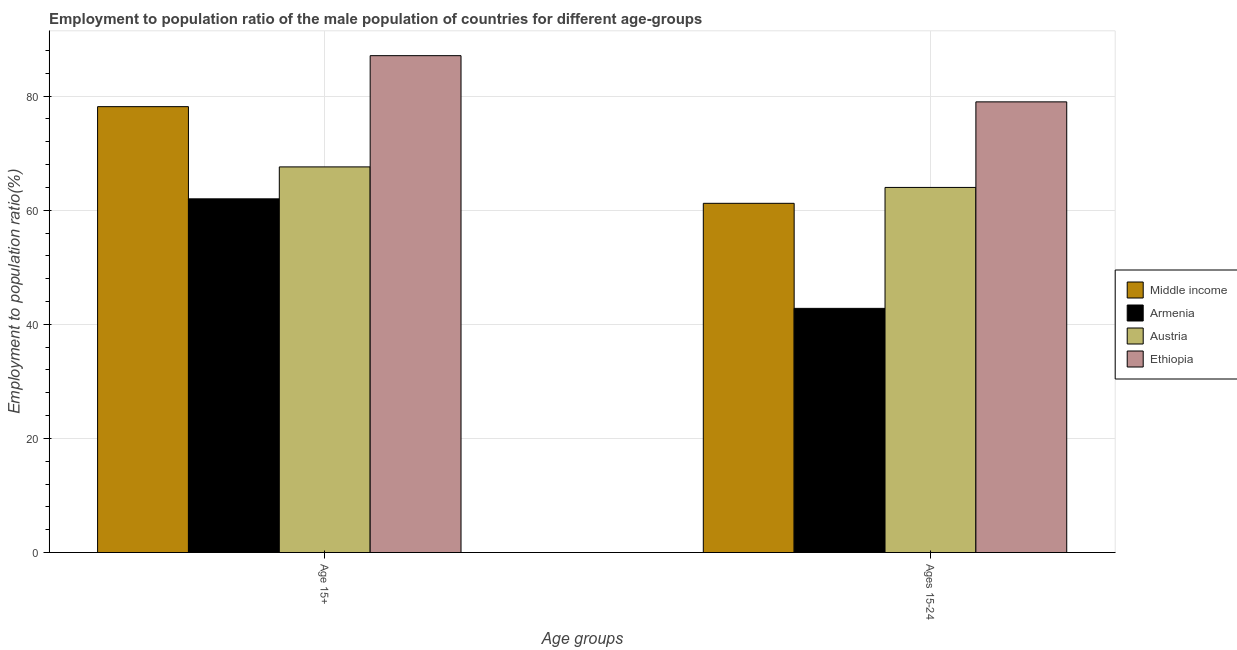How many different coloured bars are there?
Provide a succinct answer. 4. How many groups of bars are there?
Make the answer very short. 2. What is the label of the 2nd group of bars from the left?
Your answer should be very brief. Ages 15-24. What is the employment to population ratio(age 15+) in Armenia?
Offer a very short reply. 62. Across all countries, what is the maximum employment to population ratio(age 15-24)?
Keep it short and to the point. 79. Across all countries, what is the minimum employment to population ratio(age 15-24)?
Offer a terse response. 42.8. In which country was the employment to population ratio(age 15-24) maximum?
Provide a succinct answer. Ethiopia. In which country was the employment to population ratio(age 15-24) minimum?
Provide a short and direct response. Armenia. What is the total employment to population ratio(age 15-24) in the graph?
Keep it short and to the point. 247.01. What is the difference between the employment to population ratio(age 15+) in Armenia and that in Middle income?
Make the answer very short. -16.16. What is the difference between the employment to population ratio(age 15+) in Ethiopia and the employment to population ratio(age 15-24) in Middle income?
Offer a very short reply. 25.89. What is the average employment to population ratio(age 15-24) per country?
Provide a succinct answer. 61.75. What is the difference between the employment to population ratio(age 15+) and employment to population ratio(age 15-24) in Ethiopia?
Your answer should be very brief. 8.1. What is the ratio of the employment to population ratio(age 15+) in Armenia to that in Austria?
Your response must be concise. 0.92. What does the 1st bar from the left in Ages 15-24 represents?
Your response must be concise. Middle income. What does the 3rd bar from the right in Age 15+ represents?
Make the answer very short. Armenia. How many bars are there?
Your answer should be compact. 8. How many countries are there in the graph?
Your response must be concise. 4. What is the difference between two consecutive major ticks on the Y-axis?
Make the answer very short. 20. Are the values on the major ticks of Y-axis written in scientific E-notation?
Provide a short and direct response. No. Does the graph contain any zero values?
Your answer should be compact. No. How are the legend labels stacked?
Your answer should be compact. Vertical. What is the title of the graph?
Your response must be concise. Employment to population ratio of the male population of countries for different age-groups. What is the label or title of the X-axis?
Provide a succinct answer. Age groups. What is the Employment to population ratio(%) in Middle income in Age 15+?
Ensure brevity in your answer.  78.16. What is the Employment to population ratio(%) in Armenia in Age 15+?
Give a very brief answer. 62. What is the Employment to population ratio(%) of Austria in Age 15+?
Your answer should be compact. 67.6. What is the Employment to population ratio(%) of Ethiopia in Age 15+?
Keep it short and to the point. 87.1. What is the Employment to population ratio(%) of Middle income in Ages 15-24?
Make the answer very short. 61.21. What is the Employment to population ratio(%) of Armenia in Ages 15-24?
Provide a short and direct response. 42.8. What is the Employment to population ratio(%) in Ethiopia in Ages 15-24?
Make the answer very short. 79. Across all Age groups, what is the maximum Employment to population ratio(%) of Middle income?
Provide a succinct answer. 78.16. Across all Age groups, what is the maximum Employment to population ratio(%) of Austria?
Keep it short and to the point. 67.6. Across all Age groups, what is the maximum Employment to population ratio(%) in Ethiopia?
Provide a succinct answer. 87.1. Across all Age groups, what is the minimum Employment to population ratio(%) in Middle income?
Offer a terse response. 61.21. Across all Age groups, what is the minimum Employment to population ratio(%) of Armenia?
Keep it short and to the point. 42.8. Across all Age groups, what is the minimum Employment to population ratio(%) in Ethiopia?
Provide a short and direct response. 79. What is the total Employment to population ratio(%) in Middle income in the graph?
Your answer should be compact. 139.38. What is the total Employment to population ratio(%) of Armenia in the graph?
Ensure brevity in your answer.  104.8. What is the total Employment to population ratio(%) of Austria in the graph?
Keep it short and to the point. 131.6. What is the total Employment to population ratio(%) in Ethiopia in the graph?
Ensure brevity in your answer.  166.1. What is the difference between the Employment to population ratio(%) in Middle income in Age 15+ and that in Ages 15-24?
Provide a short and direct response. 16.95. What is the difference between the Employment to population ratio(%) in Austria in Age 15+ and that in Ages 15-24?
Your answer should be very brief. 3.6. What is the difference between the Employment to population ratio(%) in Ethiopia in Age 15+ and that in Ages 15-24?
Your answer should be compact. 8.1. What is the difference between the Employment to population ratio(%) in Middle income in Age 15+ and the Employment to population ratio(%) in Armenia in Ages 15-24?
Give a very brief answer. 35.36. What is the difference between the Employment to population ratio(%) of Middle income in Age 15+ and the Employment to population ratio(%) of Austria in Ages 15-24?
Provide a succinct answer. 14.16. What is the difference between the Employment to population ratio(%) of Middle income in Age 15+ and the Employment to population ratio(%) of Ethiopia in Ages 15-24?
Give a very brief answer. -0.84. What is the average Employment to population ratio(%) of Middle income per Age groups?
Your response must be concise. 69.69. What is the average Employment to population ratio(%) in Armenia per Age groups?
Provide a short and direct response. 52.4. What is the average Employment to population ratio(%) of Austria per Age groups?
Your response must be concise. 65.8. What is the average Employment to population ratio(%) in Ethiopia per Age groups?
Provide a succinct answer. 83.05. What is the difference between the Employment to population ratio(%) of Middle income and Employment to population ratio(%) of Armenia in Age 15+?
Keep it short and to the point. 16.16. What is the difference between the Employment to population ratio(%) of Middle income and Employment to population ratio(%) of Austria in Age 15+?
Give a very brief answer. 10.56. What is the difference between the Employment to population ratio(%) in Middle income and Employment to population ratio(%) in Ethiopia in Age 15+?
Ensure brevity in your answer.  -8.94. What is the difference between the Employment to population ratio(%) in Armenia and Employment to population ratio(%) in Austria in Age 15+?
Ensure brevity in your answer.  -5.6. What is the difference between the Employment to population ratio(%) of Armenia and Employment to population ratio(%) of Ethiopia in Age 15+?
Ensure brevity in your answer.  -25.1. What is the difference between the Employment to population ratio(%) of Austria and Employment to population ratio(%) of Ethiopia in Age 15+?
Ensure brevity in your answer.  -19.5. What is the difference between the Employment to population ratio(%) of Middle income and Employment to population ratio(%) of Armenia in Ages 15-24?
Ensure brevity in your answer.  18.41. What is the difference between the Employment to population ratio(%) in Middle income and Employment to population ratio(%) in Austria in Ages 15-24?
Provide a succinct answer. -2.79. What is the difference between the Employment to population ratio(%) in Middle income and Employment to population ratio(%) in Ethiopia in Ages 15-24?
Ensure brevity in your answer.  -17.79. What is the difference between the Employment to population ratio(%) of Armenia and Employment to population ratio(%) of Austria in Ages 15-24?
Offer a terse response. -21.2. What is the difference between the Employment to population ratio(%) of Armenia and Employment to population ratio(%) of Ethiopia in Ages 15-24?
Your answer should be compact. -36.2. What is the difference between the Employment to population ratio(%) of Austria and Employment to population ratio(%) of Ethiopia in Ages 15-24?
Offer a terse response. -15. What is the ratio of the Employment to population ratio(%) of Middle income in Age 15+ to that in Ages 15-24?
Your response must be concise. 1.28. What is the ratio of the Employment to population ratio(%) of Armenia in Age 15+ to that in Ages 15-24?
Offer a terse response. 1.45. What is the ratio of the Employment to population ratio(%) in Austria in Age 15+ to that in Ages 15-24?
Keep it short and to the point. 1.06. What is the ratio of the Employment to population ratio(%) of Ethiopia in Age 15+ to that in Ages 15-24?
Make the answer very short. 1.1. What is the difference between the highest and the second highest Employment to population ratio(%) in Middle income?
Your answer should be compact. 16.95. What is the difference between the highest and the second highest Employment to population ratio(%) in Armenia?
Offer a terse response. 19.2. What is the difference between the highest and the second highest Employment to population ratio(%) in Austria?
Offer a very short reply. 3.6. What is the difference between the highest and the lowest Employment to population ratio(%) of Middle income?
Make the answer very short. 16.95. What is the difference between the highest and the lowest Employment to population ratio(%) of Armenia?
Offer a very short reply. 19.2. 